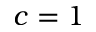Convert formula to latex. <formula><loc_0><loc_0><loc_500><loc_500>c = 1</formula> 